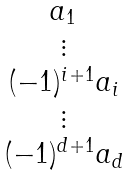Convert formula to latex. <formula><loc_0><loc_0><loc_500><loc_500>\begin{matrix} a _ { 1 } \\ \vdots \\ ( - 1 ) ^ { i + 1 } a _ { i } \\ \vdots \\ ( - 1 ) ^ { d + 1 } a _ { d } \end{matrix}</formula> 